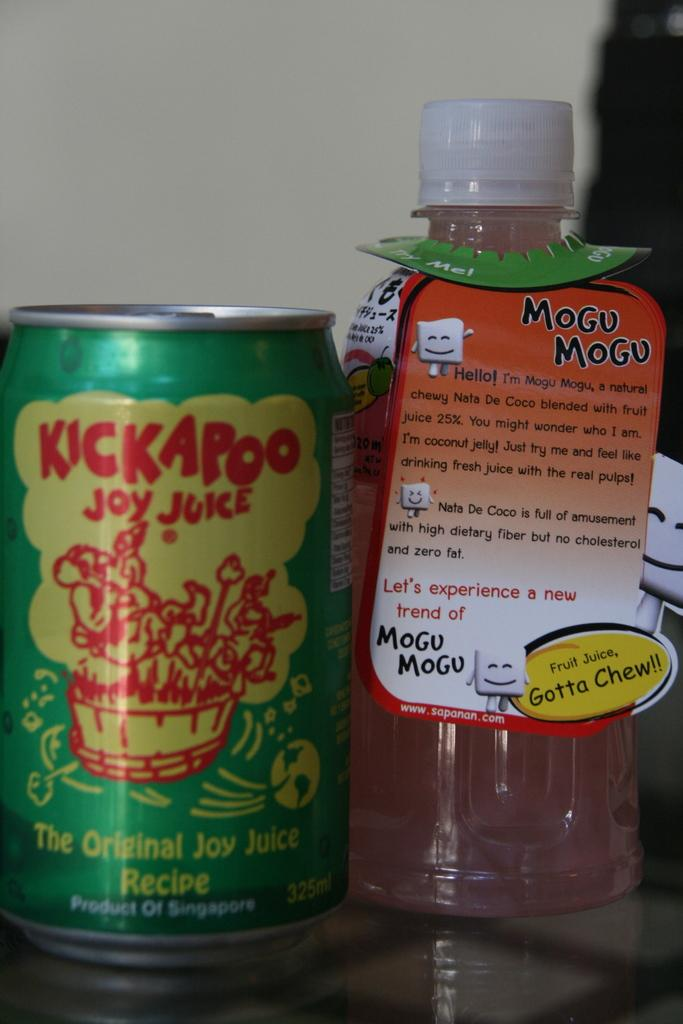<image>
Summarize the visual content of the image. A bottle of Mogu Mogu and A can of KickAPoo sit next to each other on a table. 